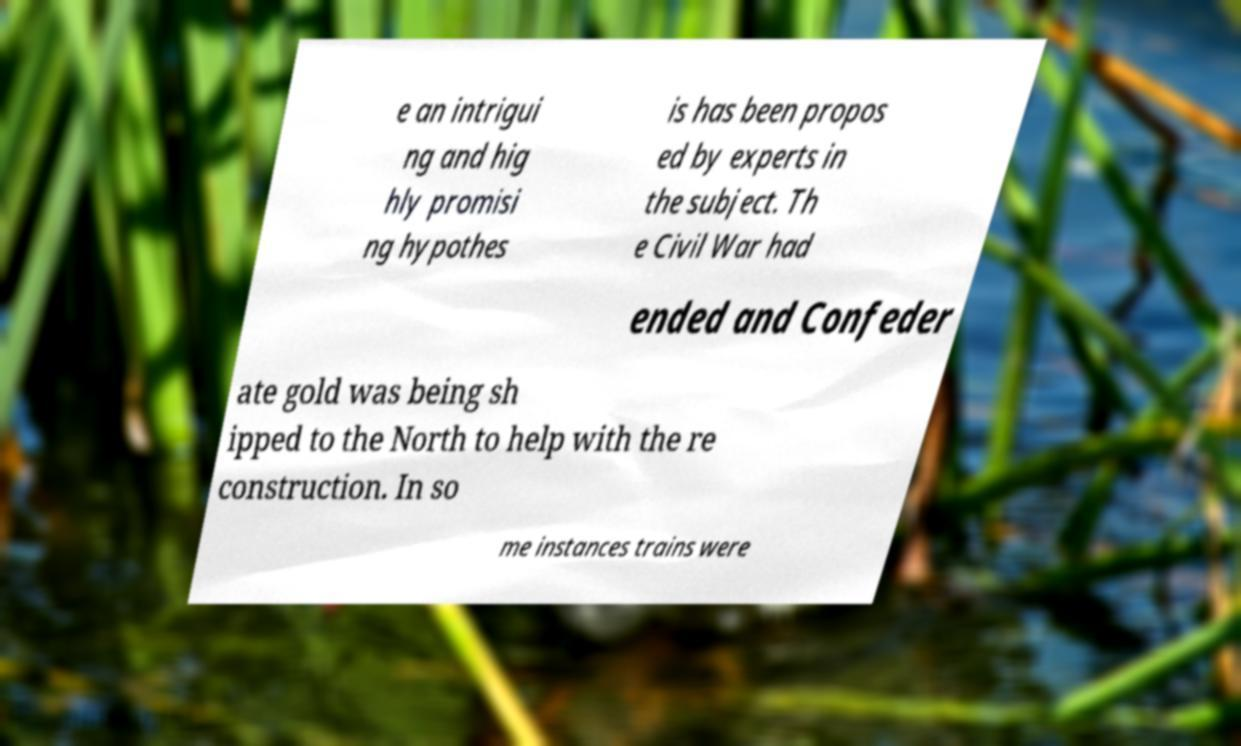Please identify and transcribe the text found in this image. e an intrigui ng and hig hly promisi ng hypothes is has been propos ed by experts in the subject. Th e Civil War had ended and Confeder ate gold was being sh ipped to the North to help with the re construction. In so me instances trains were 